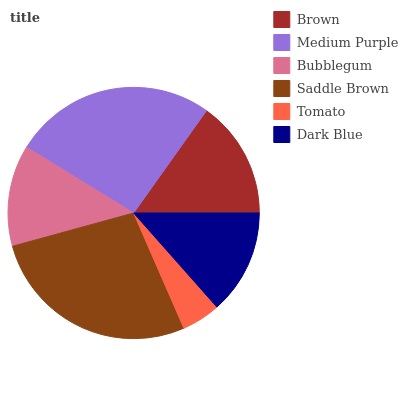Is Tomato the minimum?
Answer yes or no. Yes. Is Saddle Brown the maximum?
Answer yes or no. Yes. Is Medium Purple the minimum?
Answer yes or no. No. Is Medium Purple the maximum?
Answer yes or no. No. Is Medium Purple greater than Brown?
Answer yes or no. Yes. Is Brown less than Medium Purple?
Answer yes or no. Yes. Is Brown greater than Medium Purple?
Answer yes or no. No. Is Medium Purple less than Brown?
Answer yes or no. No. Is Brown the high median?
Answer yes or no. Yes. Is Dark Blue the low median?
Answer yes or no. Yes. Is Medium Purple the high median?
Answer yes or no. No. Is Saddle Brown the low median?
Answer yes or no. No. 